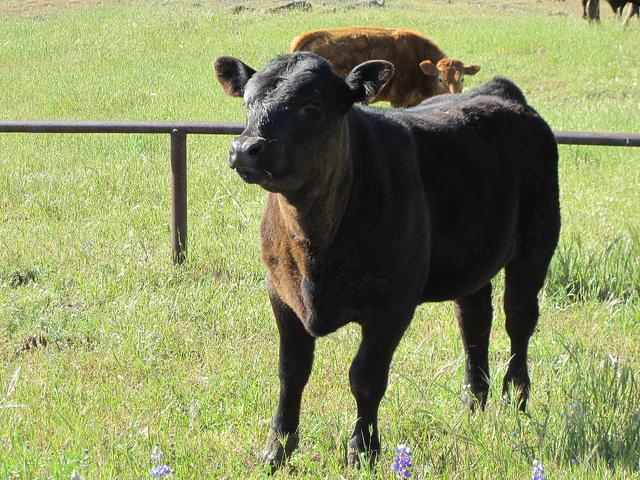Which cow is darker?
Give a very brief answer. One in front. Does the black cow weigh more than 200 pounds?
Quick response, please. Yes. Where is the fence made of pipe?
Answer briefly. Metal. 